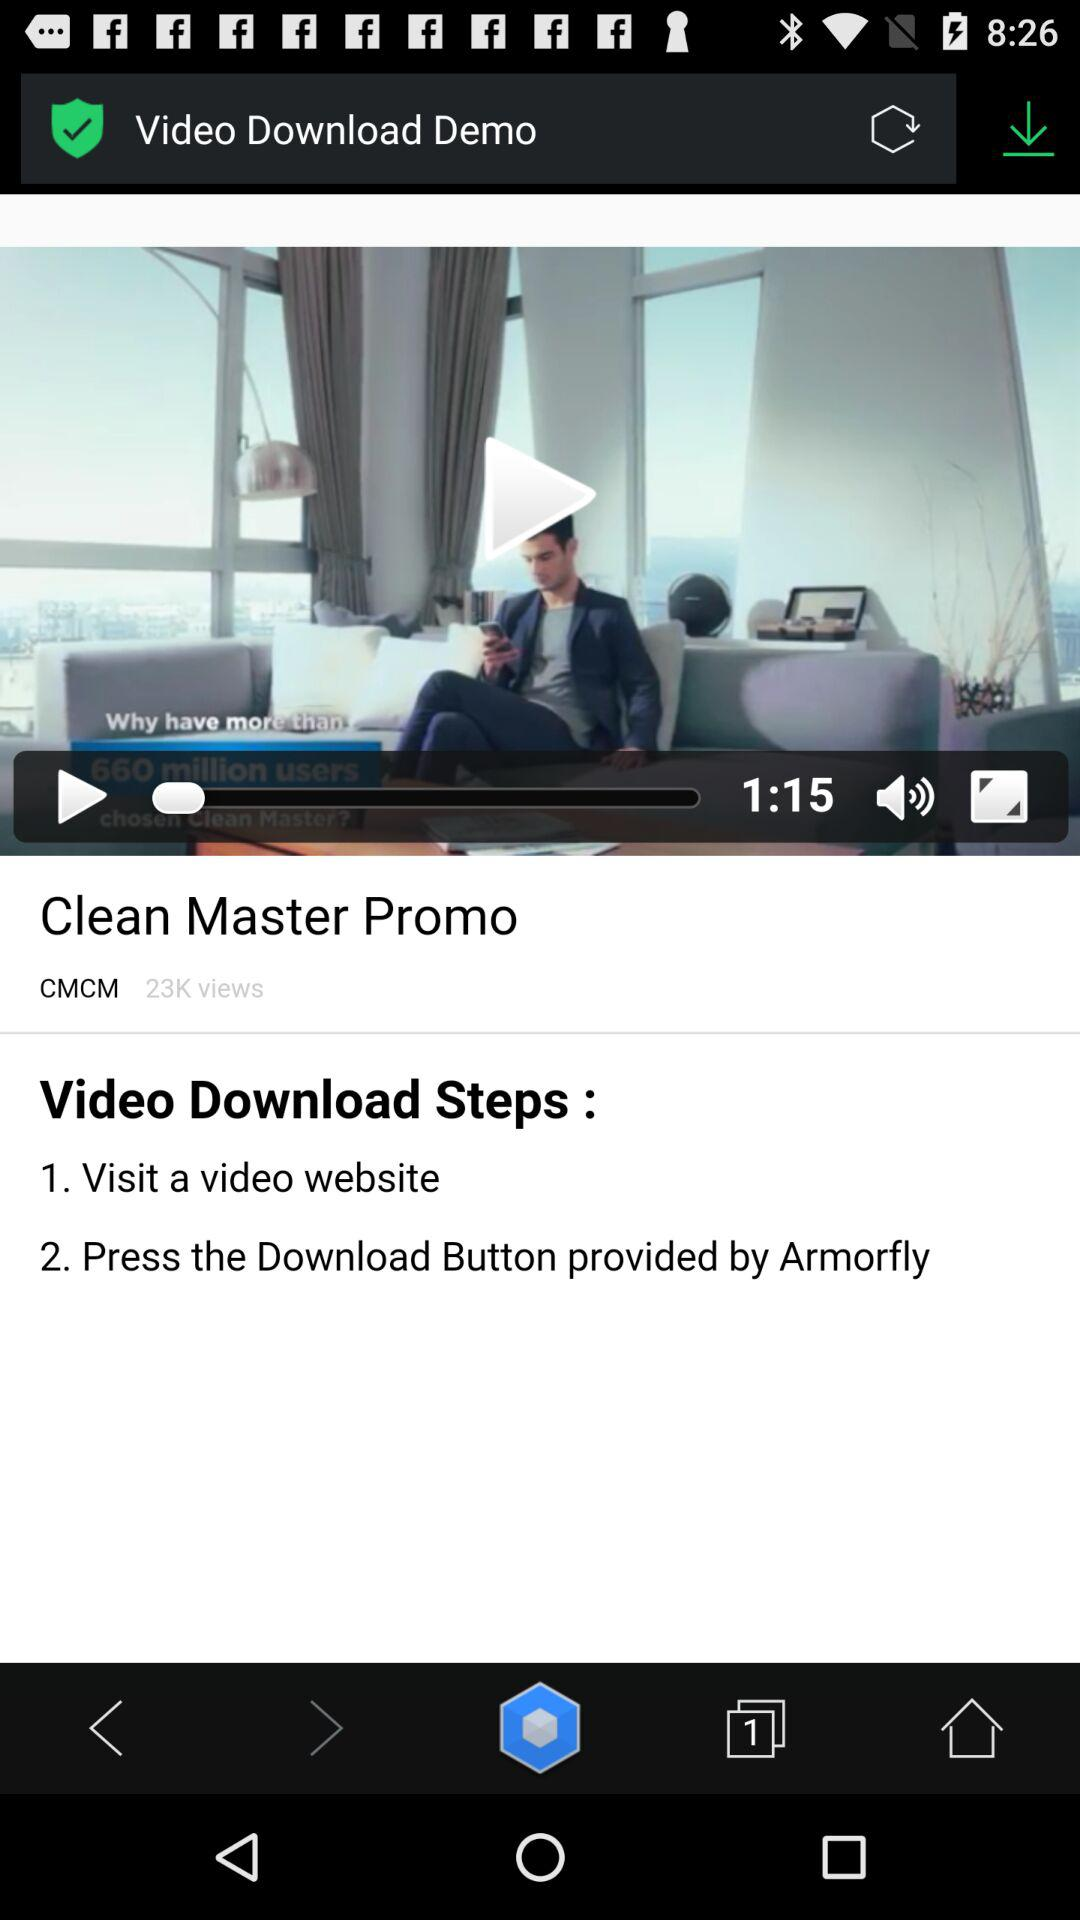How many steps are there in the video download process?
Answer the question using a single word or phrase. 2 